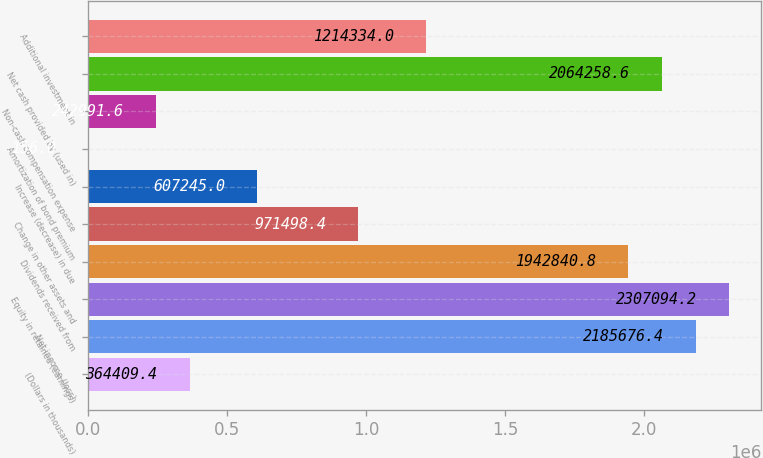Convert chart to OTSL. <chart><loc_0><loc_0><loc_500><loc_500><bar_chart><fcel>(Dollars in thousands)<fcel>Net income (loss)<fcel>Equity in retained (earnings)<fcel>Dividends received from<fcel>Change in other assets and<fcel>Increase (decrease) in due<fcel>Amortization of bond premium<fcel>Non-cash compensation expense<fcel>Net cash provided by (used in)<fcel>Additional investment in<nl><fcel>364409<fcel>2.18568e+06<fcel>2.30709e+06<fcel>1.94284e+06<fcel>971498<fcel>607245<fcel>156<fcel>242992<fcel>2.06426e+06<fcel>1.21433e+06<nl></chart> 